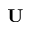<formula> <loc_0><loc_0><loc_500><loc_500>U</formula> 